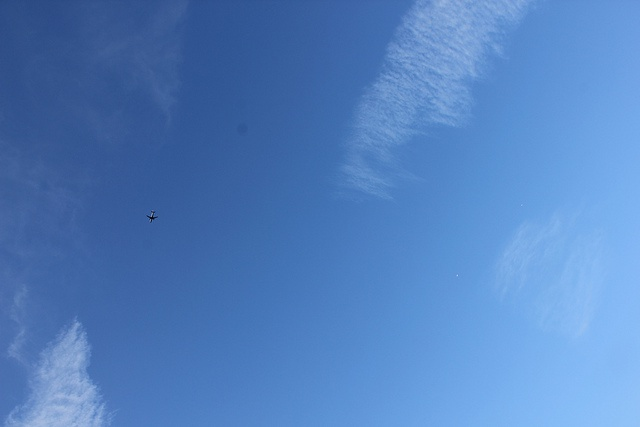Describe the objects in this image and their specific colors. I can see a airplane in darkblue, blue, black, and navy tones in this image. 